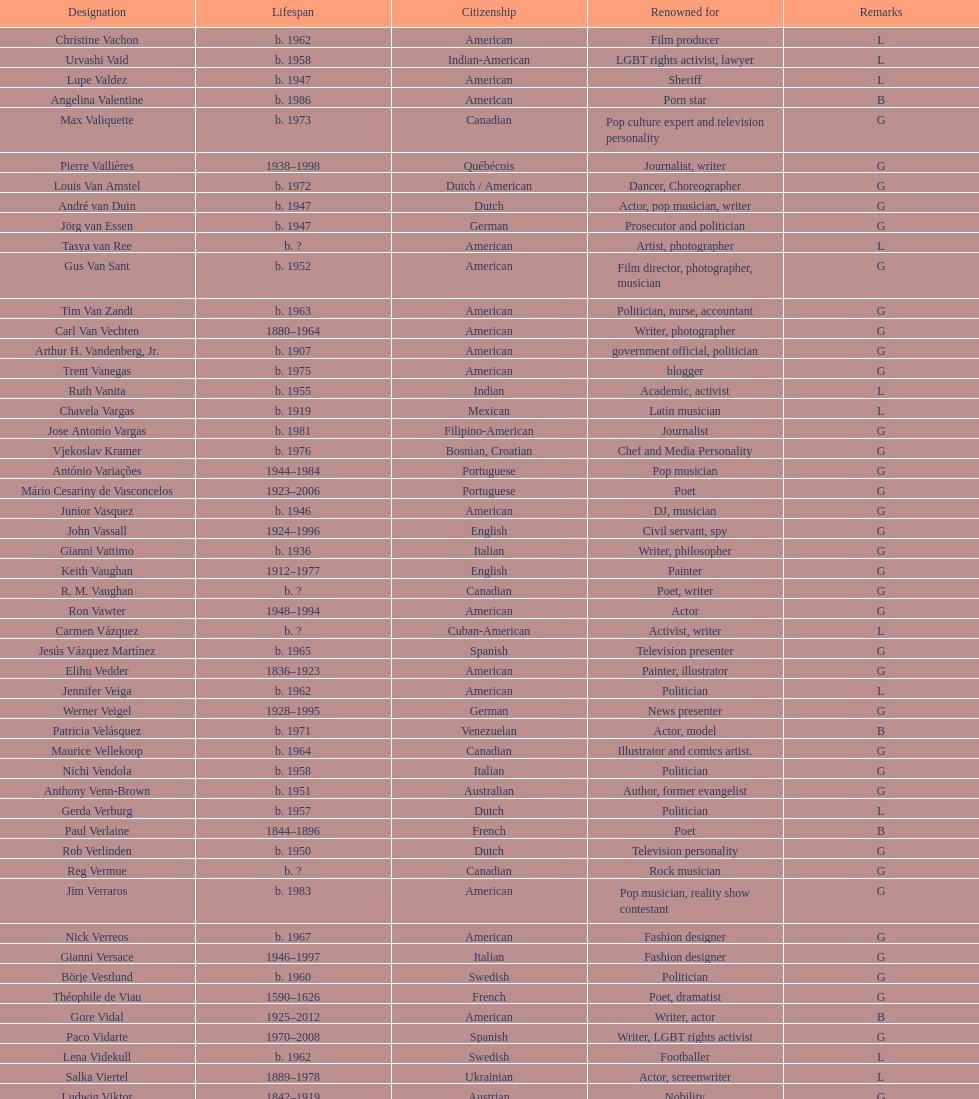Who was canadian, van amstel or valiquette? Valiquette. Could you help me parse every detail presented in this table? {'header': ['Designation', 'Lifespan', 'Citizenship', 'Renowned for', 'Remarks'], 'rows': [['Christine Vachon', 'b. 1962', 'American', 'Film producer', 'L'], ['Urvashi Vaid', 'b. 1958', 'Indian-American', 'LGBT rights activist, lawyer', 'L'], ['Lupe Valdez', 'b. 1947', 'American', 'Sheriff', 'L'], ['Angelina Valentine', 'b. 1986', 'American', 'Porn star', 'B'], ['Max Valiquette', 'b. 1973', 'Canadian', 'Pop culture expert and television personality', 'G'], ['Pierre Vallières', '1938–1998', 'Québécois', 'Journalist, writer', 'G'], ['Louis Van Amstel', 'b. 1972', 'Dutch / American', 'Dancer, Choreographer', 'G'], ['André van Duin', 'b. 1947', 'Dutch', 'Actor, pop musician, writer', 'G'], ['Jörg van Essen', 'b. 1947', 'German', 'Prosecutor and politician', 'G'], ['Tasya van Ree', 'b.\xa0?', 'American', 'Artist, photographer', 'L'], ['Gus Van Sant', 'b. 1952', 'American', 'Film director, photographer, musician', 'G'], ['Tim Van Zandt', 'b. 1963', 'American', 'Politician, nurse, accountant', 'G'], ['Carl Van Vechten', '1880–1964', 'American', 'Writer, photographer', 'G'], ['Arthur H. Vandenberg, Jr.', 'b. 1907', 'American', 'government official, politician', 'G'], ['Trent Vanegas', 'b. 1975', 'American', 'blogger', 'G'], ['Ruth Vanita', 'b. 1955', 'Indian', 'Academic, activist', 'L'], ['Chavela Vargas', 'b. 1919', 'Mexican', 'Latin musician', 'L'], ['Jose Antonio Vargas', 'b. 1981', 'Filipino-American', 'Journalist', 'G'], ['Vjekoslav Kramer', 'b. 1976', 'Bosnian, Croatian', 'Chef and Media Personality', 'G'], ['António Variações', '1944–1984', 'Portuguese', 'Pop musician', 'G'], ['Mário Cesariny de Vasconcelos', '1923–2006', 'Portuguese', 'Poet', 'G'], ['Junior Vasquez', 'b. 1946', 'American', 'DJ, musician', 'G'], ['John Vassall', '1924–1996', 'English', 'Civil servant, spy', 'G'], ['Gianni Vattimo', 'b. 1936', 'Italian', 'Writer, philosopher', 'G'], ['Keith Vaughan', '1912–1977', 'English', 'Painter', 'G'], ['R. M. Vaughan', 'b.\xa0?', 'Canadian', 'Poet, writer', 'G'], ['Ron Vawter', '1948–1994', 'American', 'Actor', 'G'], ['Carmen Vázquez', 'b.\xa0?', 'Cuban-American', 'Activist, writer', 'L'], ['Jesús Vázquez Martínez', 'b. 1965', 'Spanish', 'Television presenter', 'G'], ['Elihu Vedder', '1836–1923', 'American', 'Painter, illustrator', 'G'], ['Jennifer Veiga', 'b. 1962', 'American', 'Politician', 'L'], ['Werner Veigel', '1928–1995', 'German', 'News presenter', 'G'], ['Patricia Velásquez', 'b. 1971', 'Venezuelan', 'Actor, model', 'B'], ['Maurice Vellekoop', 'b. 1964', 'Canadian', 'Illustrator and comics artist.', 'G'], ['Nichi Vendola', 'b. 1958', 'Italian', 'Politician', 'G'], ['Anthony Venn-Brown', 'b. 1951', 'Australian', 'Author, former evangelist', 'G'], ['Gerda Verburg', 'b. 1957', 'Dutch', 'Politician', 'L'], ['Paul Verlaine', '1844–1896', 'French', 'Poet', 'B'], ['Rob Verlinden', 'b. 1950', 'Dutch', 'Television personality', 'G'], ['Reg Vermue', 'b.\xa0?', 'Canadian', 'Rock musician', 'G'], ['Jim Verraros', 'b. 1983', 'American', 'Pop musician, reality show contestant', 'G'], ['Nick Verreos', 'b. 1967', 'American', 'Fashion designer', 'G'], ['Gianni Versace', '1946–1997', 'Italian', 'Fashion designer', 'G'], ['Börje Vestlund', 'b. 1960', 'Swedish', 'Politician', 'G'], ['Théophile de Viau', '1590–1626', 'French', 'Poet, dramatist', 'G'], ['Gore Vidal', '1925–2012', 'American', 'Writer, actor', 'B'], ['Paco Vidarte', '1970–2008', 'Spanish', 'Writer, LGBT rights activist', 'G'], ['Lena Videkull', 'b. 1962', 'Swedish', 'Footballer', 'L'], ['Salka Viertel', '1889–1978', 'Ukrainian', 'Actor, screenwriter', 'L'], ['Ludwig Viktor', '1842–1919', 'Austrian', 'Nobility', 'G'], ['Bruce Vilanch', 'b. 1948', 'American', 'Comedy writer, actor', 'G'], ['Tom Villard', '1953–1994', 'American', 'Actor', 'G'], ['José Villarrubia', 'b. 1961', 'American', 'Artist', 'G'], ['Xavier Villaurrutia', '1903–1950', 'Mexican', 'Poet, playwright', 'G'], ["Alain-Philippe Malagnac d'Argens de Villèle", '1950–2000', 'French', 'Aristocrat', 'G'], ['Norah Vincent', 'b.\xa0?', 'American', 'Journalist', 'L'], ['Donald Vining', '1917–1998', 'American', 'Writer', 'G'], ['Luchino Visconti', '1906–1976', 'Italian', 'Filmmaker', 'G'], ['Pavel Vítek', 'b. 1962', 'Czech', 'Pop musician, actor', 'G'], ['Renée Vivien', '1877–1909', 'English', 'Poet', 'L'], ['Claude Vivier', '1948–1983', 'Canadian', '20th century classical composer', 'G'], ['Taylor Vixen', 'b. 1983', 'American', 'Porn star', 'B'], ['Bruce Voeller', '1934–1994', 'American', 'HIV/AIDS researcher', 'G'], ['Paula Vogel', 'b. 1951', 'American', 'Playwright', 'L'], ['Julia Volkova', 'b. 1985', 'Russian', 'Singer', 'B'], ['Jörg van Essen', 'b. 1947', 'German', 'Politician', 'G'], ['Ole von Beust', 'b. 1955', 'German', 'Politician', 'G'], ['Wilhelm von Gloeden', '1856–1931', 'German', 'Photographer', 'G'], ['Rosa von Praunheim', 'b. 1942', 'German', 'Film director', 'G'], ['Kurt von Ruffin', 'b. 1901–1996', 'German', 'Holocaust survivor', 'G'], ['Hella von Sinnen', 'b. 1959', 'German', 'Comedian', 'L'], ['Daniel Vosovic', 'b. 1981', 'American', 'Fashion designer', 'G'], ['Delwin Vriend', 'b. 1966', 'Canadian', 'LGBT rights activist', 'G']]} 